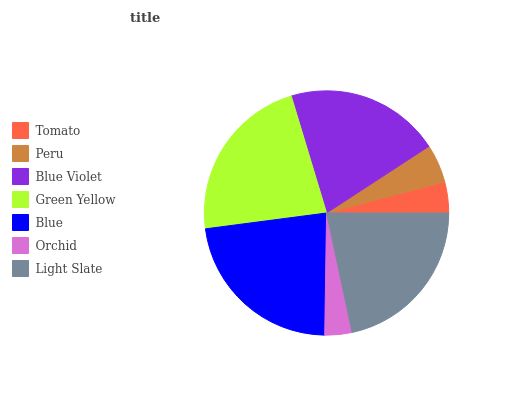Is Orchid the minimum?
Answer yes or no. Yes. Is Blue the maximum?
Answer yes or no. Yes. Is Peru the minimum?
Answer yes or no. No. Is Peru the maximum?
Answer yes or no. No. Is Peru greater than Tomato?
Answer yes or no. Yes. Is Tomato less than Peru?
Answer yes or no. Yes. Is Tomato greater than Peru?
Answer yes or no. No. Is Peru less than Tomato?
Answer yes or no. No. Is Blue Violet the high median?
Answer yes or no. Yes. Is Blue Violet the low median?
Answer yes or no. Yes. Is Light Slate the high median?
Answer yes or no. No. Is Orchid the low median?
Answer yes or no. No. 